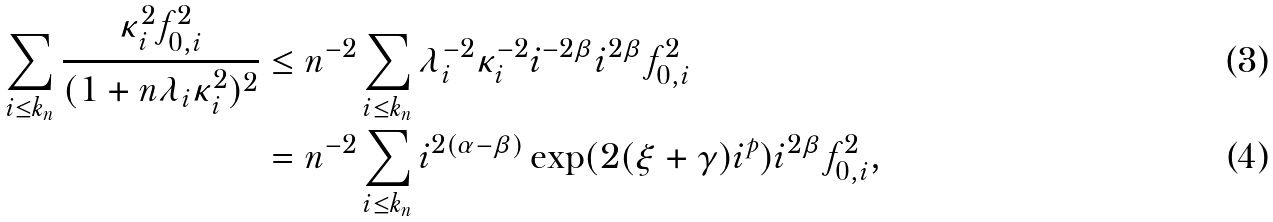Convert formula to latex. <formula><loc_0><loc_0><loc_500><loc_500>\sum _ { i \leq k _ { n } } \frac { \kappa _ { i } ^ { 2 } f _ { 0 , i } ^ { 2 } } { ( 1 + n \lambda _ { i } \kappa _ { i } ^ { 2 } ) ^ { 2 } } & \leq n ^ { - 2 } \sum _ { i \leq k _ { n } } \lambda _ { i } ^ { - 2 } \kappa _ { i } ^ { - 2 } i ^ { - 2 \beta } i ^ { 2 \beta } f _ { 0 , i } ^ { 2 } \\ & = n ^ { - 2 } \sum _ { i \leq k _ { n } } i ^ { 2 ( \alpha - \beta ) } \exp ( 2 ( \xi + \gamma ) i ^ { p } ) i ^ { 2 \beta } f _ { 0 , i } ^ { 2 } ,</formula> 